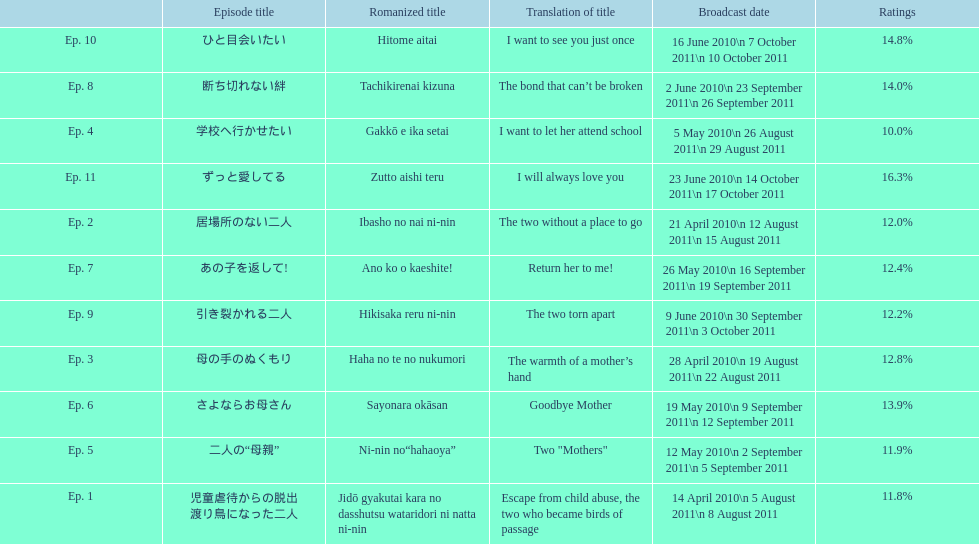How many episodes were broadcast in april 2010 in japan? 3. 